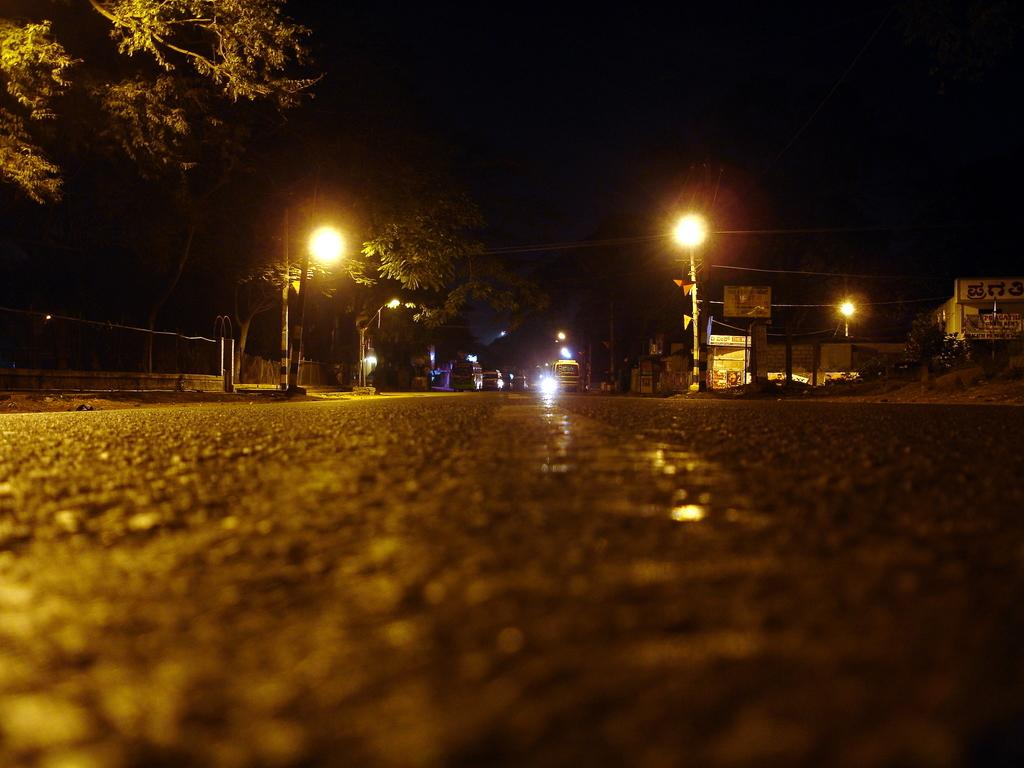What is the main structure in the center of the image? There is a building in the center of the image. What type of natural elements can be seen in the image? There are trees in the image. What might be used for illumination in the image? Lights are present in the image. What are the poles likely used for in the image? The poles are likely used for supporting lights or other objects in the image. What type of transportation is visible in the image? Vehicles are in the image. What type of surface can be seen in the image? There is a road in the image. Can you describe any other objects in the image? There are a few other objects in the image, but their specific details are not mentioned in the provided facts. What type of ear is visible on the scarecrow in the image? There is no scarecrow present in the image, so there is no ear to be seen. 